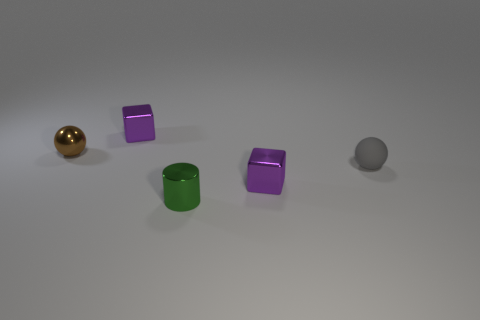What number of other objects have the same material as the tiny green object?
Your answer should be compact. 3. Is the small ball that is to the left of the tiny shiny cylinder made of the same material as the small green thing?
Provide a succinct answer. Yes. Is there anything else that has the same material as the green cylinder?
Offer a terse response. Yes. The metallic cylinder that is the same size as the brown ball is what color?
Your answer should be compact. Green. Are there any other small metallic cylinders of the same color as the cylinder?
Provide a succinct answer. No. The brown sphere that is the same material as the small cylinder is what size?
Provide a succinct answer. Small. What number of other objects are there of the same size as the matte ball?
Offer a very short reply. 4. What is the material of the brown object that is behind the small green shiny thing?
Offer a terse response. Metal. There is a small purple object that is in front of the object that is right of the small purple thing that is in front of the small gray rubber sphere; what shape is it?
Keep it short and to the point. Cube. Is the size of the green object the same as the brown ball?
Keep it short and to the point. Yes. 